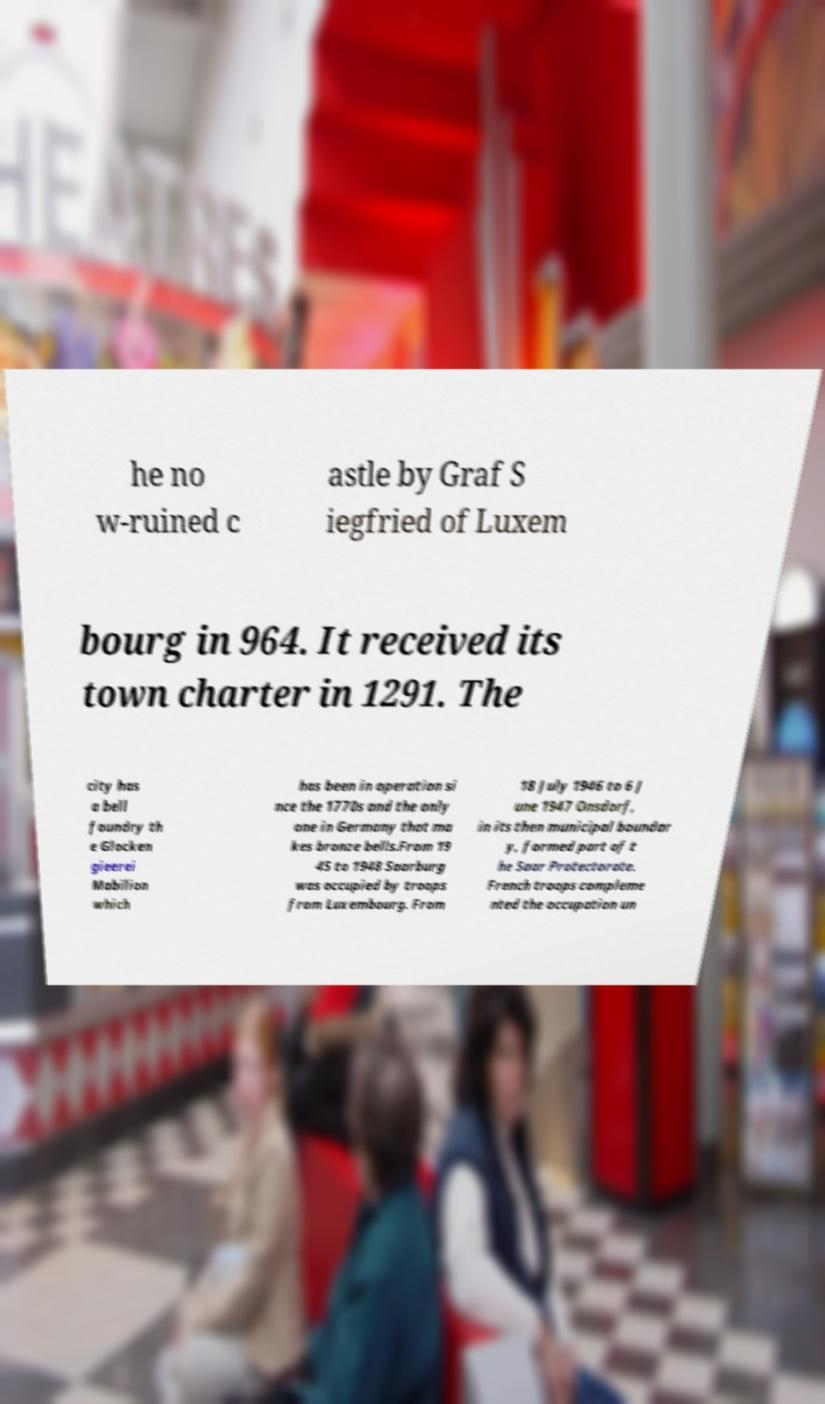What messages or text are displayed in this image? I need them in a readable, typed format. he no w-ruined c astle by Graf S iegfried of Luxem bourg in 964. It received its town charter in 1291. The city has a bell foundry th e Glocken gieerei Mabilion which has been in operation si nce the 1770s and the only one in Germany that ma kes bronze bells.From 19 45 to 1948 Saarburg was occupied by troops from Luxembourg. From 18 July 1946 to 6 J une 1947 Onsdorf, in its then municipal boundar y, formed part of t he Saar Protectorate. French troops compleme nted the occupation un 